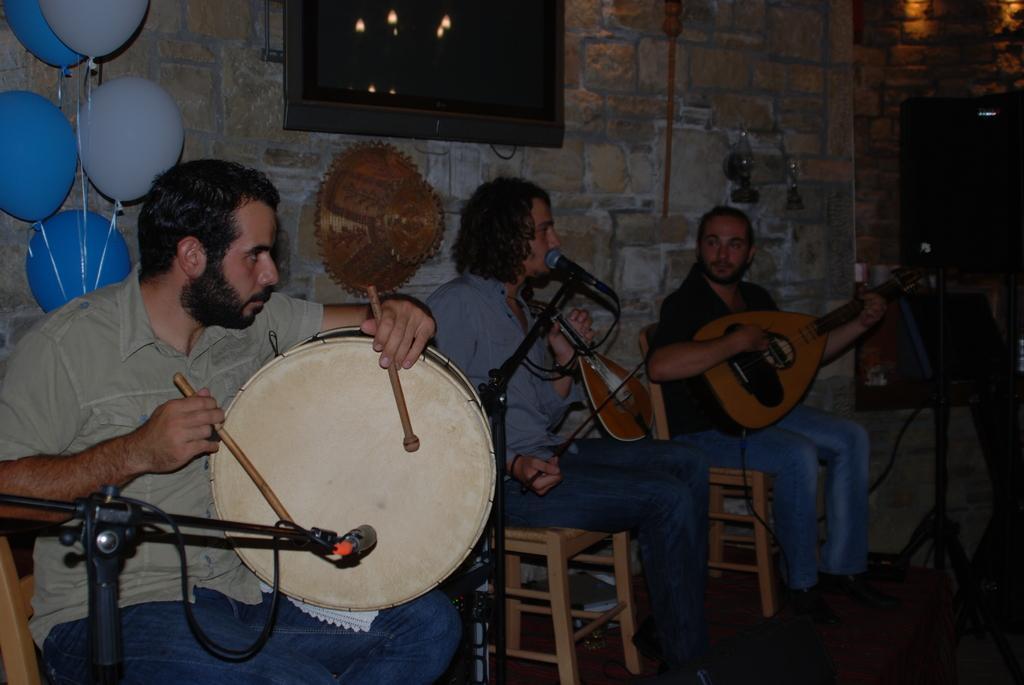Describe this image in one or two sentences. in the middle of the image few persons are playing some musical instruments. Behind them there is a wall, On the wall there is a screen. Top left side of the image there are some balloons. 